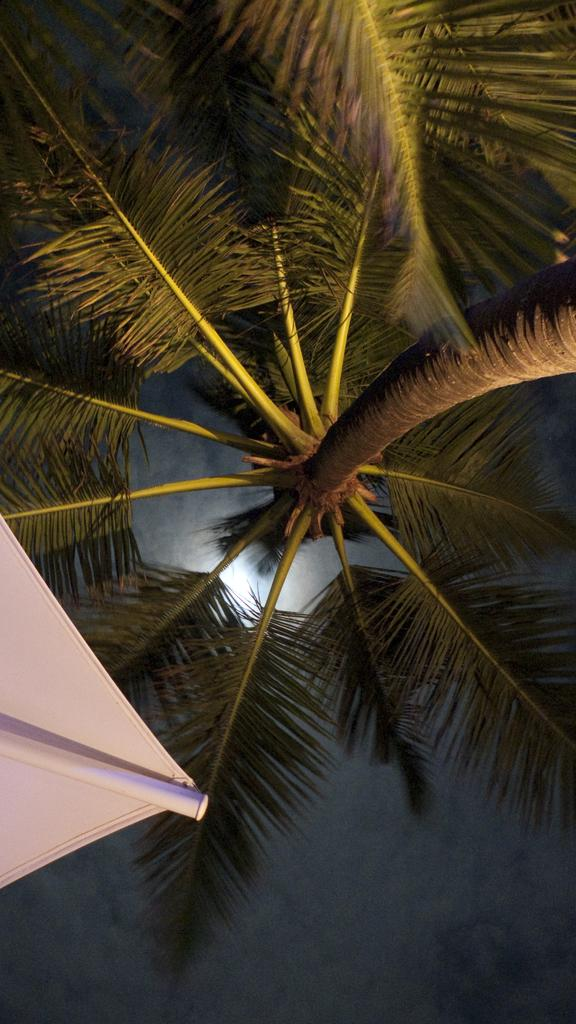What is the lighting condition in the image? The image is clicked in the dark. What natural element can be seen in the image? There is a tree in the image. What color object is present in the image? There is a white color object in the image. Where is the pole located in the image? The pole is on the left side of the image. What month is depicted in the image? The image does not depict a specific month; it only shows a tree, a pole, and a white object in the dark. Can you see a scarecrow in the image? There is no scarecrow present in the image. 